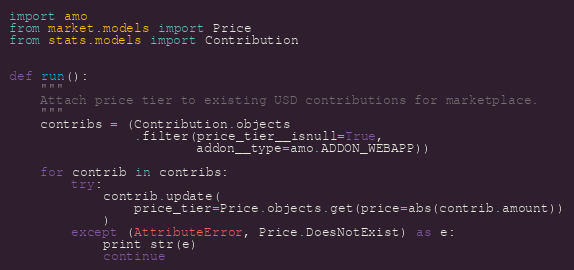Convert code to text. <code><loc_0><loc_0><loc_500><loc_500><_Python_>import amo
from market.models import Price
from stats.models import Contribution


def run():
    """
    Attach price tier to existing USD contributions for marketplace.
    """
    contribs = (Contribution.objects
                .filter(price_tier__isnull=True,
                        addon__type=amo.ADDON_WEBAPP))

    for contrib in contribs:
        try:
            contrib.update(
                price_tier=Price.objects.get(price=abs(contrib.amount))
            )
        except (AttributeError, Price.DoesNotExist) as e:
            print str(e)
            continue
</code> 